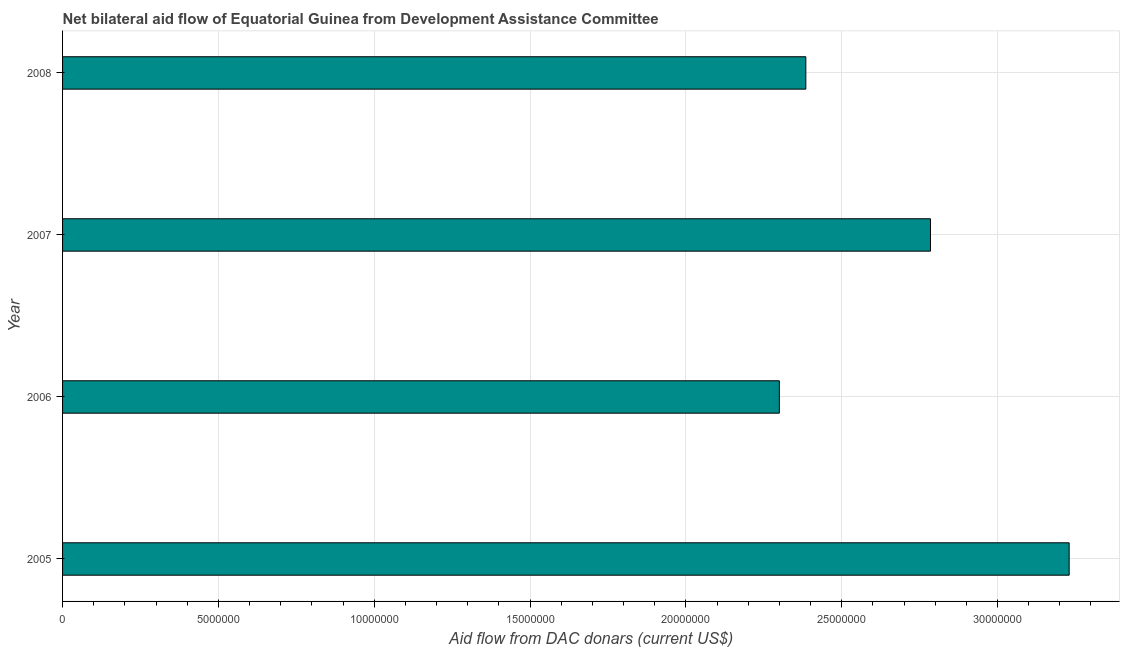What is the title of the graph?
Provide a succinct answer. Net bilateral aid flow of Equatorial Guinea from Development Assistance Committee. What is the label or title of the X-axis?
Offer a terse response. Aid flow from DAC donars (current US$). What is the net bilateral aid flows from dac donors in 2007?
Your response must be concise. 2.78e+07. Across all years, what is the maximum net bilateral aid flows from dac donors?
Keep it short and to the point. 3.23e+07. Across all years, what is the minimum net bilateral aid flows from dac donors?
Your answer should be compact. 2.30e+07. In which year was the net bilateral aid flows from dac donors minimum?
Your response must be concise. 2006. What is the sum of the net bilateral aid flows from dac donors?
Make the answer very short. 1.07e+08. What is the difference between the net bilateral aid flows from dac donors in 2005 and 2007?
Provide a short and direct response. 4.45e+06. What is the average net bilateral aid flows from dac donors per year?
Offer a terse response. 2.68e+07. What is the median net bilateral aid flows from dac donors?
Your answer should be compact. 2.58e+07. In how many years, is the net bilateral aid flows from dac donors greater than 3000000 US$?
Ensure brevity in your answer.  4. Do a majority of the years between 2006 and 2005 (inclusive) have net bilateral aid flows from dac donors greater than 29000000 US$?
Offer a terse response. No. What is the ratio of the net bilateral aid flows from dac donors in 2005 to that in 2006?
Your answer should be compact. 1.4. What is the difference between the highest and the second highest net bilateral aid flows from dac donors?
Make the answer very short. 4.45e+06. What is the difference between the highest and the lowest net bilateral aid flows from dac donors?
Ensure brevity in your answer.  9.30e+06. In how many years, is the net bilateral aid flows from dac donors greater than the average net bilateral aid flows from dac donors taken over all years?
Your answer should be very brief. 2. How many bars are there?
Give a very brief answer. 4. How many years are there in the graph?
Provide a succinct answer. 4. What is the Aid flow from DAC donars (current US$) of 2005?
Provide a short and direct response. 3.23e+07. What is the Aid flow from DAC donars (current US$) of 2006?
Offer a very short reply. 2.30e+07. What is the Aid flow from DAC donars (current US$) of 2007?
Make the answer very short. 2.78e+07. What is the Aid flow from DAC donars (current US$) in 2008?
Keep it short and to the point. 2.38e+07. What is the difference between the Aid flow from DAC donars (current US$) in 2005 and 2006?
Make the answer very short. 9.30e+06. What is the difference between the Aid flow from DAC donars (current US$) in 2005 and 2007?
Give a very brief answer. 4.45e+06. What is the difference between the Aid flow from DAC donars (current US$) in 2005 and 2008?
Provide a succinct answer. 8.45e+06. What is the difference between the Aid flow from DAC donars (current US$) in 2006 and 2007?
Provide a succinct answer. -4.85e+06. What is the difference between the Aid flow from DAC donars (current US$) in 2006 and 2008?
Your answer should be compact. -8.50e+05. What is the difference between the Aid flow from DAC donars (current US$) in 2007 and 2008?
Your answer should be very brief. 4.00e+06. What is the ratio of the Aid flow from DAC donars (current US$) in 2005 to that in 2006?
Offer a terse response. 1.4. What is the ratio of the Aid flow from DAC donars (current US$) in 2005 to that in 2007?
Your answer should be very brief. 1.16. What is the ratio of the Aid flow from DAC donars (current US$) in 2005 to that in 2008?
Your answer should be very brief. 1.35. What is the ratio of the Aid flow from DAC donars (current US$) in 2006 to that in 2007?
Offer a terse response. 0.83. What is the ratio of the Aid flow from DAC donars (current US$) in 2007 to that in 2008?
Your answer should be very brief. 1.17. 